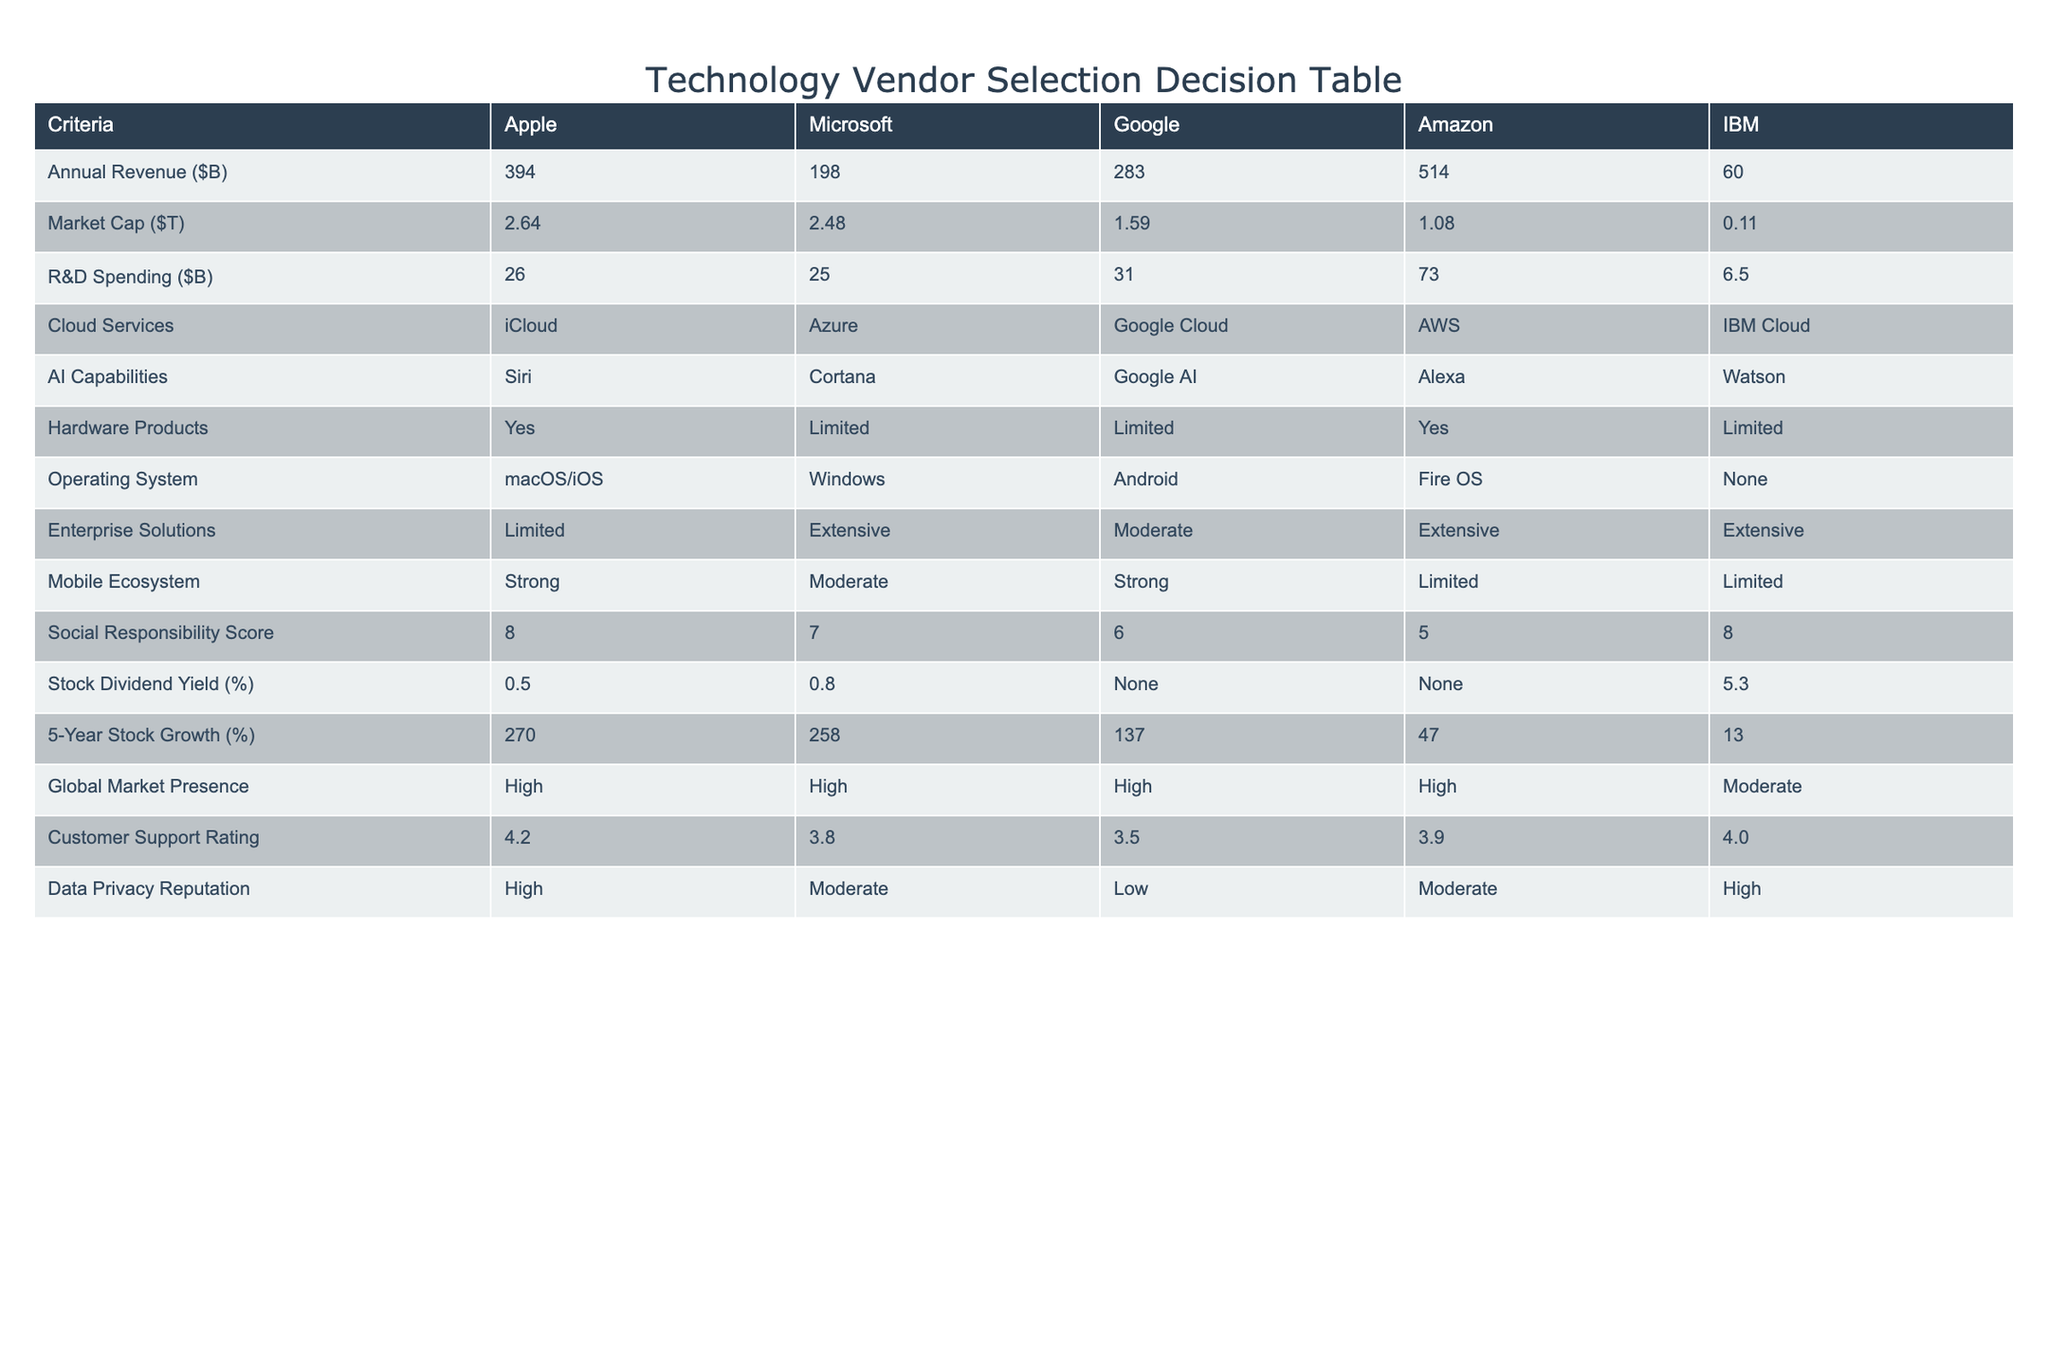What is the Annual Revenue of Amazon? In the table, the Annual Revenue for Amazon is listed in the second row of the first column. The value shown is 514 billion dollars.
Answer: 514 Which company has the highest Market Cap? The Market Cap values are provided in the second row. Comparing the values, Apple's Market Cap is 2.64 trillion, which is greater than the others: Microsoft (2.48), Google (1.59), Amazon (1.08), and IBM (0.11).
Answer: Apple What is the average R&D Spending of all vendors? To calculate the average, sum the R&D Spending values: 26 + 25 + 31 + 73 + 6.5 = 161.5. Then divide by the number of companies (5): 161.5 / 5 = 32.3.
Answer: 32.3 Which company has Limited Hardware Products? By checking the Hardware Products column, the companies marked as having Limited Hardware Products are Microsoft, Google, and IBM.
Answer: Microsoft, Google, IBM Is IBM Cloud a cloud service provider? Looking at the Cloud Services column, IBM Cloud is listed under IBM, confirming that IBM is a cloud service provider.
Answer: Yes How much higher is Apple’s 5-Year Stock Growth compared to IBM's? Apple's 5-Year Stock Growth is 270%, while IBM's is 13%. The difference is calculated by subtracting IBM's growth from Apple's: 270 - 13 = 257.
Answer: 257 What is the Social Responsibility Score of the company with the highest AI capabilities? The company with the highest AI capabilities is Google with a rating in the AI Capabilities column. Looking at the Social Responsibility Score for Google in the respective column, it is 6.
Answer: 6 Which two companies have the highest Customer Support Rating? The Customer Support Ratings for the companies are 4.2 for Apple, 3.8 for Microsoft, 3.5 for Google, 3.9 for Amazon, and 4.0 for IBM. The two highest ratings are those of Apple (4.2) and IBM (4.0).
Answer: Apple, IBM Is it true that Amazon has a moderate Global Market Presence? In the Global Market Presence column, Amazon is rated High. Therefore, the statement regarding Amazon having a moderate presence is incorrect.
Answer: No 